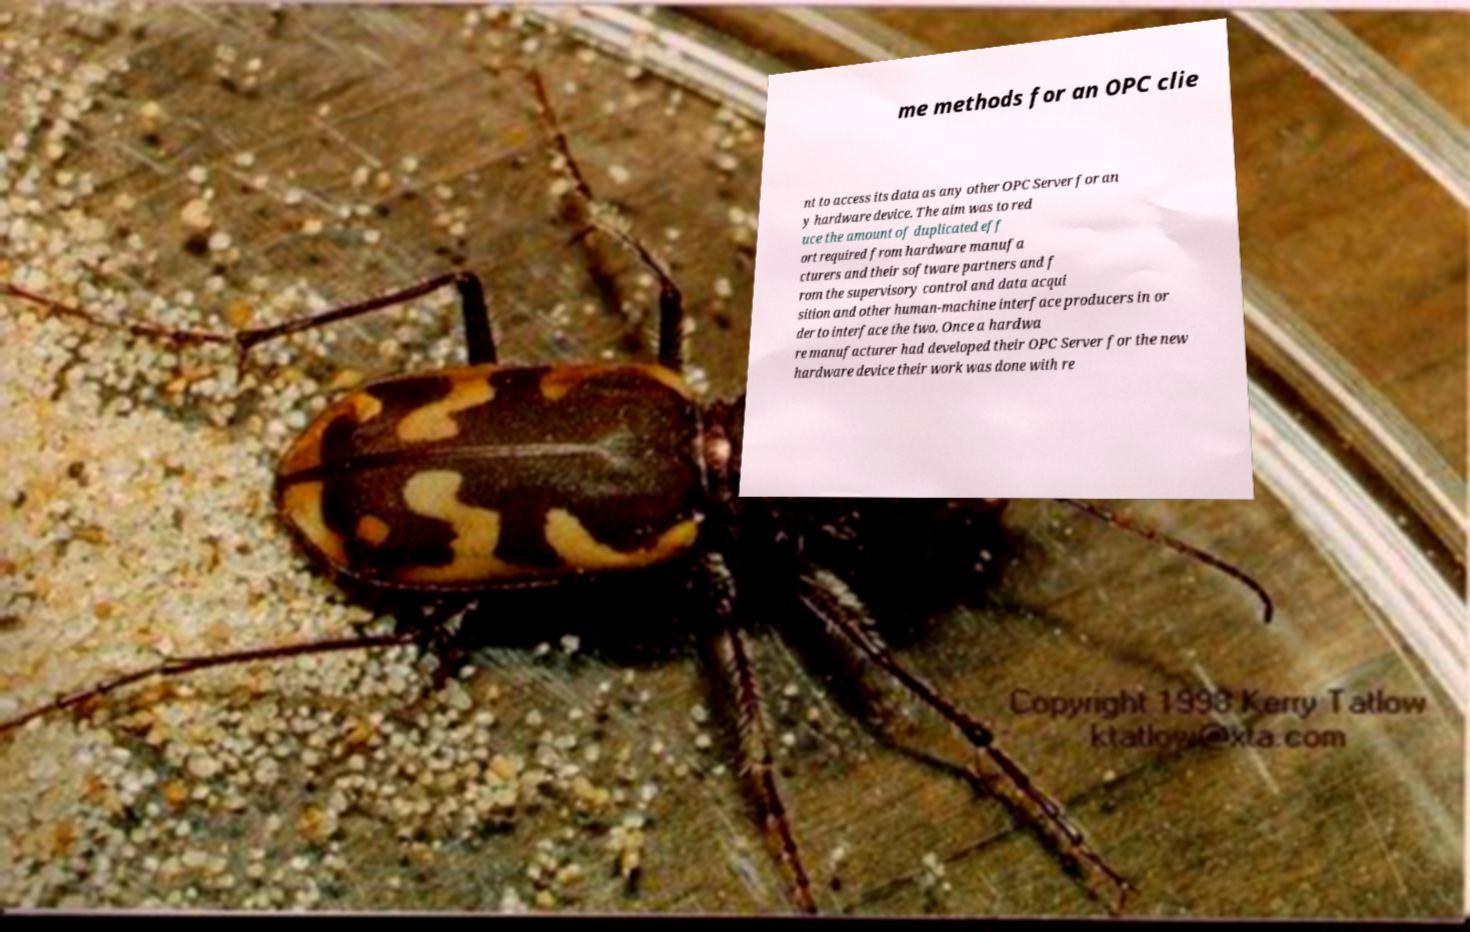Can you read and provide the text displayed in the image?This photo seems to have some interesting text. Can you extract and type it out for me? me methods for an OPC clie nt to access its data as any other OPC Server for an y hardware device. The aim was to red uce the amount of duplicated eff ort required from hardware manufa cturers and their software partners and f rom the supervisory control and data acqui sition and other human-machine interface producers in or der to interface the two. Once a hardwa re manufacturer had developed their OPC Server for the new hardware device their work was done with re 